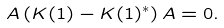Convert formula to latex. <formula><loc_0><loc_0><loc_500><loc_500>A \left ( K ( 1 ) - K ( 1 ) ^ { * } \right ) A = 0 .</formula> 